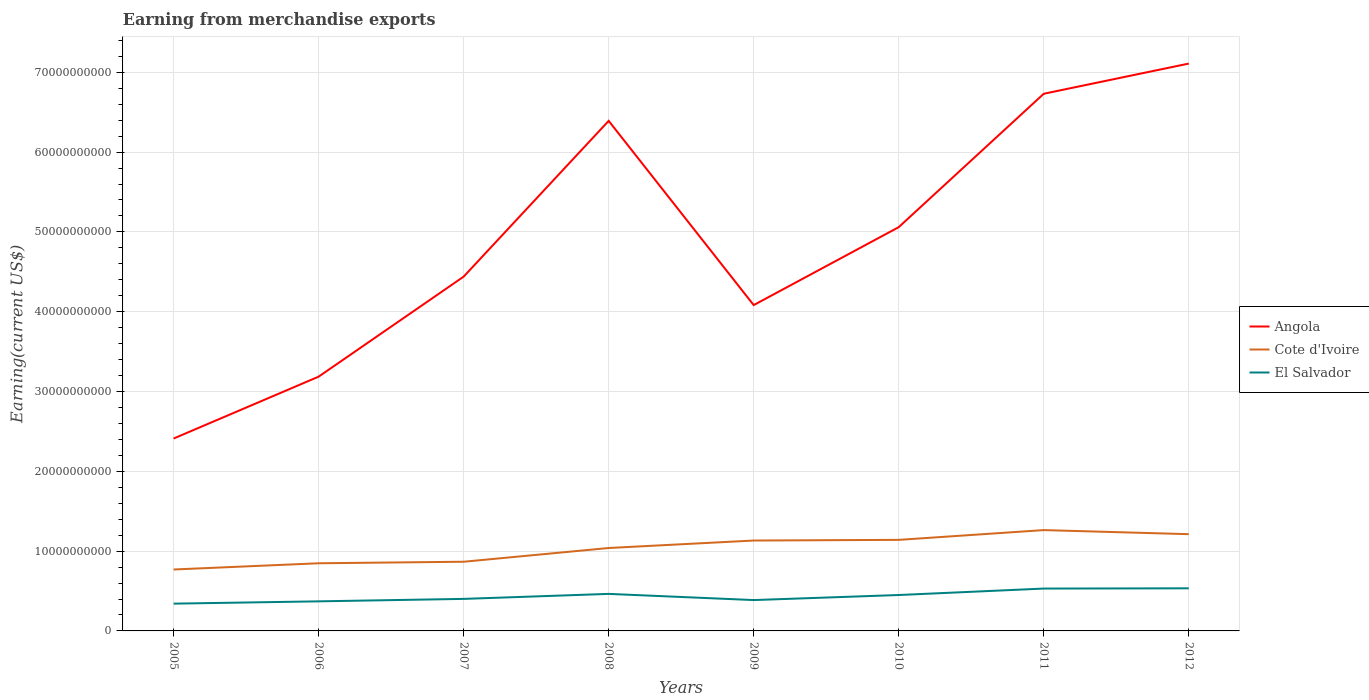How many different coloured lines are there?
Provide a short and direct response. 3. Is the number of lines equal to the number of legend labels?
Provide a short and direct response. Yes. Across all years, what is the maximum amount earned from merchandise exports in Angola?
Ensure brevity in your answer.  2.41e+1. In which year was the amount earned from merchandise exports in El Salvador maximum?
Your response must be concise. 2005. What is the total amount earned from merchandise exports in Cote d'Ivoire in the graph?
Your answer should be compact. -2.74e+09. What is the difference between the highest and the second highest amount earned from merchandise exports in El Salvador?
Keep it short and to the point. 1.92e+09. What is the difference between the highest and the lowest amount earned from merchandise exports in El Salvador?
Provide a short and direct response. 4. How many lines are there?
Provide a short and direct response. 3. How many years are there in the graph?
Provide a short and direct response. 8. What is the difference between two consecutive major ticks on the Y-axis?
Your answer should be very brief. 1.00e+1. Does the graph contain grids?
Offer a terse response. Yes. Where does the legend appear in the graph?
Your answer should be very brief. Center right. How many legend labels are there?
Give a very brief answer. 3. What is the title of the graph?
Your response must be concise. Earning from merchandise exports. What is the label or title of the X-axis?
Provide a short and direct response. Years. What is the label or title of the Y-axis?
Your answer should be compact. Earning(current US$). What is the Earning(current US$) in Angola in 2005?
Your response must be concise. 2.41e+1. What is the Earning(current US$) of Cote d'Ivoire in 2005?
Your answer should be very brief. 7.70e+09. What is the Earning(current US$) of El Salvador in 2005?
Your answer should be compact. 3.42e+09. What is the Earning(current US$) in Angola in 2006?
Offer a very short reply. 3.19e+1. What is the Earning(current US$) in Cote d'Ivoire in 2006?
Keep it short and to the point. 8.48e+09. What is the Earning(current US$) of El Salvador in 2006?
Make the answer very short. 3.71e+09. What is the Earning(current US$) in Angola in 2007?
Offer a very short reply. 4.44e+1. What is the Earning(current US$) in Cote d'Ivoire in 2007?
Your answer should be very brief. 8.67e+09. What is the Earning(current US$) of El Salvador in 2007?
Make the answer very short. 4.01e+09. What is the Earning(current US$) of Angola in 2008?
Your answer should be compact. 6.39e+1. What is the Earning(current US$) of Cote d'Ivoire in 2008?
Provide a short and direct response. 1.04e+1. What is the Earning(current US$) in El Salvador in 2008?
Your answer should be compact. 4.64e+09. What is the Earning(current US$) of Angola in 2009?
Your response must be concise. 4.08e+1. What is the Earning(current US$) of Cote d'Ivoire in 2009?
Offer a very short reply. 1.13e+1. What is the Earning(current US$) in El Salvador in 2009?
Give a very brief answer. 3.87e+09. What is the Earning(current US$) of Angola in 2010?
Offer a terse response. 5.06e+1. What is the Earning(current US$) in Cote d'Ivoire in 2010?
Offer a terse response. 1.14e+1. What is the Earning(current US$) in El Salvador in 2010?
Provide a short and direct response. 4.50e+09. What is the Earning(current US$) of Angola in 2011?
Offer a terse response. 6.73e+1. What is the Earning(current US$) of Cote d'Ivoire in 2011?
Give a very brief answer. 1.26e+1. What is the Earning(current US$) in El Salvador in 2011?
Provide a short and direct response. 5.31e+09. What is the Earning(current US$) in Angola in 2012?
Offer a very short reply. 7.11e+1. What is the Earning(current US$) of Cote d'Ivoire in 2012?
Your response must be concise. 1.21e+1. What is the Earning(current US$) of El Salvador in 2012?
Your answer should be compact. 5.34e+09. Across all years, what is the maximum Earning(current US$) in Angola?
Your response must be concise. 7.11e+1. Across all years, what is the maximum Earning(current US$) of Cote d'Ivoire?
Make the answer very short. 1.26e+1. Across all years, what is the maximum Earning(current US$) in El Salvador?
Ensure brevity in your answer.  5.34e+09. Across all years, what is the minimum Earning(current US$) of Angola?
Keep it short and to the point. 2.41e+1. Across all years, what is the minimum Earning(current US$) in Cote d'Ivoire?
Provide a short and direct response. 7.70e+09. Across all years, what is the minimum Earning(current US$) of El Salvador?
Make the answer very short. 3.42e+09. What is the total Earning(current US$) in Angola in the graph?
Make the answer very short. 3.94e+11. What is the total Earning(current US$) of Cote d'Ivoire in the graph?
Your answer should be very brief. 8.27e+1. What is the total Earning(current US$) of El Salvador in the graph?
Provide a succinct answer. 3.48e+1. What is the difference between the Earning(current US$) of Angola in 2005 and that in 2006?
Make the answer very short. -7.75e+09. What is the difference between the Earning(current US$) in Cote d'Ivoire in 2005 and that in 2006?
Give a very brief answer. -7.80e+08. What is the difference between the Earning(current US$) in El Salvador in 2005 and that in 2006?
Keep it short and to the point. -2.88e+08. What is the difference between the Earning(current US$) in Angola in 2005 and that in 2007?
Ensure brevity in your answer.  -2.03e+1. What is the difference between the Earning(current US$) in Cote d'Ivoire in 2005 and that in 2007?
Your answer should be very brief. -9.72e+08. What is the difference between the Earning(current US$) in El Salvador in 2005 and that in 2007?
Your response must be concise. -5.96e+08. What is the difference between the Earning(current US$) in Angola in 2005 and that in 2008?
Ensure brevity in your answer.  -3.98e+1. What is the difference between the Earning(current US$) of Cote d'Ivoire in 2005 and that in 2008?
Provide a succinct answer. -2.69e+09. What is the difference between the Earning(current US$) in El Salvador in 2005 and that in 2008?
Ensure brevity in your answer.  -1.22e+09. What is the difference between the Earning(current US$) of Angola in 2005 and that in 2009?
Give a very brief answer. -1.67e+1. What is the difference between the Earning(current US$) of Cote d'Ivoire in 2005 and that in 2009?
Your response must be concise. -3.63e+09. What is the difference between the Earning(current US$) in El Salvador in 2005 and that in 2009?
Your answer should be compact. -4.48e+08. What is the difference between the Earning(current US$) of Angola in 2005 and that in 2010?
Make the answer very short. -2.65e+1. What is the difference between the Earning(current US$) of Cote d'Ivoire in 2005 and that in 2010?
Your answer should be very brief. -3.71e+09. What is the difference between the Earning(current US$) in El Salvador in 2005 and that in 2010?
Your answer should be compact. -1.08e+09. What is the difference between the Earning(current US$) of Angola in 2005 and that in 2011?
Offer a terse response. -4.32e+1. What is the difference between the Earning(current US$) of Cote d'Ivoire in 2005 and that in 2011?
Offer a terse response. -4.94e+09. What is the difference between the Earning(current US$) in El Salvador in 2005 and that in 2011?
Your answer should be very brief. -1.89e+09. What is the difference between the Earning(current US$) in Angola in 2005 and that in 2012?
Offer a terse response. -4.70e+1. What is the difference between the Earning(current US$) of Cote d'Ivoire in 2005 and that in 2012?
Your response must be concise. -4.43e+09. What is the difference between the Earning(current US$) of El Salvador in 2005 and that in 2012?
Your answer should be compact. -1.92e+09. What is the difference between the Earning(current US$) of Angola in 2006 and that in 2007?
Make the answer very short. -1.25e+1. What is the difference between the Earning(current US$) in Cote d'Ivoire in 2006 and that in 2007?
Provide a short and direct response. -1.92e+08. What is the difference between the Earning(current US$) of El Salvador in 2006 and that in 2007?
Give a very brief answer. -3.08e+08. What is the difference between the Earning(current US$) of Angola in 2006 and that in 2008?
Give a very brief answer. -3.21e+1. What is the difference between the Earning(current US$) of Cote d'Ivoire in 2006 and that in 2008?
Provide a succinct answer. -1.91e+09. What is the difference between the Earning(current US$) in El Salvador in 2006 and that in 2008?
Make the answer very short. -9.35e+08. What is the difference between the Earning(current US$) in Angola in 2006 and that in 2009?
Your answer should be very brief. -8.97e+09. What is the difference between the Earning(current US$) in Cote d'Ivoire in 2006 and that in 2009?
Ensure brevity in your answer.  -2.85e+09. What is the difference between the Earning(current US$) of El Salvador in 2006 and that in 2009?
Provide a succinct answer. -1.60e+08. What is the difference between the Earning(current US$) of Angola in 2006 and that in 2010?
Provide a succinct answer. -1.87e+1. What is the difference between the Earning(current US$) in Cote d'Ivoire in 2006 and that in 2010?
Provide a succinct answer. -2.93e+09. What is the difference between the Earning(current US$) in El Salvador in 2006 and that in 2010?
Offer a very short reply. -7.93e+08. What is the difference between the Earning(current US$) in Angola in 2006 and that in 2011?
Make the answer very short. -3.54e+1. What is the difference between the Earning(current US$) in Cote d'Ivoire in 2006 and that in 2011?
Your answer should be very brief. -4.16e+09. What is the difference between the Earning(current US$) of El Salvador in 2006 and that in 2011?
Make the answer very short. -1.60e+09. What is the difference between the Earning(current US$) in Angola in 2006 and that in 2012?
Ensure brevity in your answer.  -3.92e+1. What is the difference between the Earning(current US$) of Cote d'Ivoire in 2006 and that in 2012?
Offer a terse response. -3.65e+09. What is the difference between the Earning(current US$) of El Salvador in 2006 and that in 2012?
Your answer should be compact. -1.63e+09. What is the difference between the Earning(current US$) of Angola in 2007 and that in 2008?
Make the answer very short. -1.95e+1. What is the difference between the Earning(current US$) of Cote d'Ivoire in 2007 and that in 2008?
Give a very brief answer. -1.72e+09. What is the difference between the Earning(current US$) of El Salvador in 2007 and that in 2008?
Your answer should be compact. -6.27e+08. What is the difference between the Earning(current US$) of Angola in 2007 and that in 2009?
Provide a succinct answer. 3.57e+09. What is the difference between the Earning(current US$) of Cote d'Ivoire in 2007 and that in 2009?
Offer a terse response. -2.66e+09. What is the difference between the Earning(current US$) in El Salvador in 2007 and that in 2009?
Keep it short and to the point. 1.48e+08. What is the difference between the Earning(current US$) of Angola in 2007 and that in 2010?
Ensure brevity in your answer.  -6.20e+09. What is the difference between the Earning(current US$) of Cote d'Ivoire in 2007 and that in 2010?
Ensure brevity in your answer.  -2.74e+09. What is the difference between the Earning(current US$) in El Salvador in 2007 and that in 2010?
Keep it short and to the point. -4.85e+08. What is the difference between the Earning(current US$) of Angola in 2007 and that in 2011?
Make the answer very short. -2.29e+1. What is the difference between the Earning(current US$) in Cote d'Ivoire in 2007 and that in 2011?
Provide a short and direct response. -3.97e+09. What is the difference between the Earning(current US$) of El Salvador in 2007 and that in 2011?
Make the answer very short. -1.29e+09. What is the difference between the Earning(current US$) of Angola in 2007 and that in 2012?
Provide a succinct answer. -2.67e+1. What is the difference between the Earning(current US$) in Cote d'Ivoire in 2007 and that in 2012?
Keep it short and to the point. -3.46e+09. What is the difference between the Earning(current US$) in El Salvador in 2007 and that in 2012?
Offer a terse response. -1.32e+09. What is the difference between the Earning(current US$) of Angola in 2008 and that in 2009?
Make the answer very short. 2.31e+1. What is the difference between the Earning(current US$) of Cote d'Ivoire in 2008 and that in 2009?
Provide a succinct answer. -9.37e+08. What is the difference between the Earning(current US$) in El Salvador in 2008 and that in 2009?
Give a very brief answer. 7.75e+08. What is the difference between the Earning(current US$) of Angola in 2008 and that in 2010?
Ensure brevity in your answer.  1.33e+1. What is the difference between the Earning(current US$) of Cote d'Ivoire in 2008 and that in 2010?
Your response must be concise. -1.02e+09. What is the difference between the Earning(current US$) in El Salvador in 2008 and that in 2010?
Provide a short and direct response. 1.42e+08. What is the difference between the Earning(current US$) of Angola in 2008 and that in 2011?
Provide a short and direct response. -3.40e+09. What is the difference between the Earning(current US$) in Cote d'Ivoire in 2008 and that in 2011?
Provide a succinct answer. -2.25e+09. What is the difference between the Earning(current US$) in El Salvador in 2008 and that in 2011?
Offer a terse response. -6.67e+08. What is the difference between the Earning(current US$) in Angola in 2008 and that in 2012?
Provide a succinct answer. -7.18e+09. What is the difference between the Earning(current US$) of Cote d'Ivoire in 2008 and that in 2012?
Provide a short and direct response. -1.73e+09. What is the difference between the Earning(current US$) of El Salvador in 2008 and that in 2012?
Give a very brief answer. -6.98e+08. What is the difference between the Earning(current US$) in Angola in 2009 and that in 2010?
Make the answer very short. -9.77e+09. What is the difference between the Earning(current US$) of Cote d'Ivoire in 2009 and that in 2010?
Keep it short and to the point. -8.33e+07. What is the difference between the Earning(current US$) in El Salvador in 2009 and that in 2010?
Your response must be concise. -6.33e+08. What is the difference between the Earning(current US$) in Angola in 2009 and that in 2011?
Your answer should be compact. -2.65e+1. What is the difference between the Earning(current US$) in Cote d'Ivoire in 2009 and that in 2011?
Provide a short and direct response. -1.31e+09. What is the difference between the Earning(current US$) of El Salvador in 2009 and that in 2011?
Offer a terse response. -1.44e+09. What is the difference between the Earning(current US$) of Angola in 2009 and that in 2012?
Your answer should be compact. -3.03e+1. What is the difference between the Earning(current US$) of Cote d'Ivoire in 2009 and that in 2012?
Ensure brevity in your answer.  -7.97e+08. What is the difference between the Earning(current US$) of El Salvador in 2009 and that in 2012?
Make the answer very short. -1.47e+09. What is the difference between the Earning(current US$) of Angola in 2010 and that in 2011?
Your response must be concise. -1.67e+1. What is the difference between the Earning(current US$) in Cote d'Ivoire in 2010 and that in 2011?
Ensure brevity in your answer.  -1.22e+09. What is the difference between the Earning(current US$) of El Salvador in 2010 and that in 2011?
Provide a short and direct response. -8.09e+08. What is the difference between the Earning(current US$) in Angola in 2010 and that in 2012?
Provide a succinct answer. -2.05e+1. What is the difference between the Earning(current US$) of Cote d'Ivoire in 2010 and that in 2012?
Provide a succinct answer. -7.14e+08. What is the difference between the Earning(current US$) in El Salvador in 2010 and that in 2012?
Offer a terse response. -8.40e+08. What is the difference between the Earning(current US$) of Angola in 2011 and that in 2012?
Your response must be concise. -3.78e+09. What is the difference between the Earning(current US$) in Cote d'Ivoire in 2011 and that in 2012?
Provide a short and direct response. 5.11e+08. What is the difference between the Earning(current US$) of El Salvador in 2011 and that in 2012?
Your response must be concise. -3.08e+07. What is the difference between the Earning(current US$) in Angola in 2005 and the Earning(current US$) in Cote d'Ivoire in 2006?
Offer a terse response. 1.56e+1. What is the difference between the Earning(current US$) of Angola in 2005 and the Earning(current US$) of El Salvador in 2006?
Provide a short and direct response. 2.04e+1. What is the difference between the Earning(current US$) of Cote d'Ivoire in 2005 and the Earning(current US$) of El Salvador in 2006?
Your response must be concise. 3.99e+09. What is the difference between the Earning(current US$) in Angola in 2005 and the Earning(current US$) in Cote d'Ivoire in 2007?
Your answer should be very brief. 1.54e+1. What is the difference between the Earning(current US$) of Angola in 2005 and the Earning(current US$) of El Salvador in 2007?
Give a very brief answer. 2.01e+1. What is the difference between the Earning(current US$) of Cote d'Ivoire in 2005 and the Earning(current US$) of El Salvador in 2007?
Provide a short and direct response. 3.68e+09. What is the difference between the Earning(current US$) in Angola in 2005 and the Earning(current US$) in Cote d'Ivoire in 2008?
Your response must be concise. 1.37e+1. What is the difference between the Earning(current US$) in Angola in 2005 and the Earning(current US$) in El Salvador in 2008?
Offer a very short reply. 1.95e+1. What is the difference between the Earning(current US$) of Cote d'Ivoire in 2005 and the Earning(current US$) of El Salvador in 2008?
Keep it short and to the point. 3.06e+09. What is the difference between the Earning(current US$) in Angola in 2005 and the Earning(current US$) in Cote d'Ivoire in 2009?
Keep it short and to the point. 1.28e+1. What is the difference between the Earning(current US$) in Angola in 2005 and the Earning(current US$) in El Salvador in 2009?
Keep it short and to the point. 2.02e+1. What is the difference between the Earning(current US$) in Cote d'Ivoire in 2005 and the Earning(current US$) in El Salvador in 2009?
Keep it short and to the point. 3.83e+09. What is the difference between the Earning(current US$) of Angola in 2005 and the Earning(current US$) of Cote d'Ivoire in 2010?
Offer a terse response. 1.27e+1. What is the difference between the Earning(current US$) of Angola in 2005 and the Earning(current US$) of El Salvador in 2010?
Your response must be concise. 1.96e+1. What is the difference between the Earning(current US$) of Cote d'Ivoire in 2005 and the Earning(current US$) of El Salvador in 2010?
Your answer should be very brief. 3.20e+09. What is the difference between the Earning(current US$) in Angola in 2005 and the Earning(current US$) in Cote d'Ivoire in 2011?
Offer a very short reply. 1.15e+1. What is the difference between the Earning(current US$) in Angola in 2005 and the Earning(current US$) in El Salvador in 2011?
Your answer should be compact. 1.88e+1. What is the difference between the Earning(current US$) of Cote d'Ivoire in 2005 and the Earning(current US$) of El Salvador in 2011?
Make the answer very short. 2.39e+09. What is the difference between the Earning(current US$) of Angola in 2005 and the Earning(current US$) of Cote d'Ivoire in 2012?
Offer a terse response. 1.20e+1. What is the difference between the Earning(current US$) in Angola in 2005 and the Earning(current US$) in El Salvador in 2012?
Ensure brevity in your answer.  1.88e+1. What is the difference between the Earning(current US$) in Cote d'Ivoire in 2005 and the Earning(current US$) in El Salvador in 2012?
Make the answer very short. 2.36e+09. What is the difference between the Earning(current US$) of Angola in 2006 and the Earning(current US$) of Cote d'Ivoire in 2007?
Offer a very short reply. 2.32e+1. What is the difference between the Earning(current US$) of Angola in 2006 and the Earning(current US$) of El Salvador in 2007?
Make the answer very short. 2.78e+1. What is the difference between the Earning(current US$) in Cote d'Ivoire in 2006 and the Earning(current US$) in El Salvador in 2007?
Your response must be concise. 4.46e+09. What is the difference between the Earning(current US$) of Angola in 2006 and the Earning(current US$) of Cote d'Ivoire in 2008?
Keep it short and to the point. 2.15e+1. What is the difference between the Earning(current US$) in Angola in 2006 and the Earning(current US$) in El Salvador in 2008?
Your response must be concise. 2.72e+1. What is the difference between the Earning(current US$) in Cote d'Ivoire in 2006 and the Earning(current US$) in El Salvador in 2008?
Your answer should be very brief. 3.84e+09. What is the difference between the Earning(current US$) in Angola in 2006 and the Earning(current US$) in Cote d'Ivoire in 2009?
Keep it short and to the point. 2.05e+1. What is the difference between the Earning(current US$) of Angola in 2006 and the Earning(current US$) of El Salvador in 2009?
Provide a succinct answer. 2.80e+1. What is the difference between the Earning(current US$) in Cote d'Ivoire in 2006 and the Earning(current US$) in El Salvador in 2009?
Your answer should be compact. 4.61e+09. What is the difference between the Earning(current US$) of Angola in 2006 and the Earning(current US$) of Cote d'Ivoire in 2010?
Your answer should be compact. 2.05e+1. What is the difference between the Earning(current US$) in Angola in 2006 and the Earning(current US$) in El Salvador in 2010?
Offer a very short reply. 2.74e+1. What is the difference between the Earning(current US$) of Cote d'Ivoire in 2006 and the Earning(current US$) of El Salvador in 2010?
Provide a succinct answer. 3.98e+09. What is the difference between the Earning(current US$) of Angola in 2006 and the Earning(current US$) of Cote d'Ivoire in 2011?
Your answer should be very brief. 1.92e+1. What is the difference between the Earning(current US$) of Angola in 2006 and the Earning(current US$) of El Salvador in 2011?
Your response must be concise. 2.66e+1. What is the difference between the Earning(current US$) in Cote d'Ivoire in 2006 and the Earning(current US$) in El Salvador in 2011?
Keep it short and to the point. 3.17e+09. What is the difference between the Earning(current US$) of Angola in 2006 and the Earning(current US$) of Cote d'Ivoire in 2012?
Provide a short and direct response. 1.97e+1. What is the difference between the Earning(current US$) of Angola in 2006 and the Earning(current US$) of El Salvador in 2012?
Provide a short and direct response. 2.65e+1. What is the difference between the Earning(current US$) of Cote d'Ivoire in 2006 and the Earning(current US$) of El Salvador in 2012?
Provide a succinct answer. 3.14e+09. What is the difference between the Earning(current US$) in Angola in 2007 and the Earning(current US$) in Cote d'Ivoire in 2008?
Make the answer very short. 3.40e+1. What is the difference between the Earning(current US$) in Angola in 2007 and the Earning(current US$) in El Salvador in 2008?
Ensure brevity in your answer.  3.98e+1. What is the difference between the Earning(current US$) in Cote d'Ivoire in 2007 and the Earning(current US$) in El Salvador in 2008?
Offer a terse response. 4.03e+09. What is the difference between the Earning(current US$) of Angola in 2007 and the Earning(current US$) of Cote d'Ivoire in 2009?
Make the answer very short. 3.31e+1. What is the difference between the Earning(current US$) of Angola in 2007 and the Earning(current US$) of El Salvador in 2009?
Make the answer very short. 4.05e+1. What is the difference between the Earning(current US$) in Cote d'Ivoire in 2007 and the Earning(current US$) in El Salvador in 2009?
Provide a succinct answer. 4.80e+09. What is the difference between the Earning(current US$) of Angola in 2007 and the Earning(current US$) of Cote d'Ivoire in 2010?
Your answer should be compact. 3.30e+1. What is the difference between the Earning(current US$) of Angola in 2007 and the Earning(current US$) of El Salvador in 2010?
Make the answer very short. 3.99e+1. What is the difference between the Earning(current US$) in Cote d'Ivoire in 2007 and the Earning(current US$) in El Salvador in 2010?
Your response must be concise. 4.17e+09. What is the difference between the Earning(current US$) in Angola in 2007 and the Earning(current US$) in Cote d'Ivoire in 2011?
Offer a terse response. 3.18e+1. What is the difference between the Earning(current US$) in Angola in 2007 and the Earning(current US$) in El Salvador in 2011?
Offer a terse response. 3.91e+1. What is the difference between the Earning(current US$) of Cote d'Ivoire in 2007 and the Earning(current US$) of El Salvador in 2011?
Your response must be concise. 3.36e+09. What is the difference between the Earning(current US$) in Angola in 2007 and the Earning(current US$) in Cote d'Ivoire in 2012?
Provide a succinct answer. 3.23e+1. What is the difference between the Earning(current US$) of Angola in 2007 and the Earning(current US$) of El Salvador in 2012?
Provide a succinct answer. 3.91e+1. What is the difference between the Earning(current US$) of Cote d'Ivoire in 2007 and the Earning(current US$) of El Salvador in 2012?
Your response must be concise. 3.33e+09. What is the difference between the Earning(current US$) in Angola in 2008 and the Earning(current US$) in Cote d'Ivoire in 2009?
Offer a very short reply. 5.26e+1. What is the difference between the Earning(current US$) in Angola in 2008 and the Earning(current US$) in El Salvador in 2009?
Give a very brief answer. 6.00e+1. What is the difference between the Earning(current US$) in Cote d'Ivoire in 2008 and the Earning(current US$) in El Salvador in 2009?
Give a very brief answer. 6.52e+09. What is the difference between the Earning(current US$) in Angola in 2008 and the Earning(current US$) in Cote d'Ivoire in 2010?
Provide a short and direct response. 5.25e+1. What is the difference between the Earning(current US$) in Angola in 2008 and the Earning(current US$) in El Salvador in 2010?
Provide a succinct answer. 5.94e+1. What is the difference between the Earning(current US$) in Cote d'Ivoire in 2008 and the Earning(current US$) in El Salvador in 2010?
Your response must be concise. 5.89e+09. What is the difference between the Earning(current US$) in Angola in 2008 and the Earning(current US$) in Cote d'Ivoire in 2011?
Your response must be concise. 5.13e+1. What is the difference between the Earning(current US$) of Angola in 2008 and the Earning(current US$) of El Salvador in 2011?
Your response must be concise. 5.86e+1. What is the difference between the Earning(current US$) in Cote d'Ivoire in 2008 and the Earning(current US$) in El Salvador in 2011?
Provide a succinct answer. 5.08e+09. What is the difference between the Earning(current US$) of Angola in 2008 and the Earning(current US$) of Cote d'Ivoire in 2012?
Keep it short and to the point. 5.18e+1. What is the difference between the Earning(current US$) of Angola in 2008 and the Earning(current US$) of El Salvador in 2012?
Offer a terse response. 5.86e+1. What is the difference between the Earning(current US$) of Cote d'Ivoire in 2008 and the Earning(current US$) of El Salvador in 2012?
Provide a short and direct response. 5.05e+09. What is the difference between the Earning(current US$) of Angola in 2009 and the Earning(current US$) of Cote d'Ivoire in 2010?
Keep it short and to the point. 2.94e+1. What is the difference between the Earning(current US$) of Angola in 2009 and the Earning(current US$) of El Salvador in 2010?
Provide a succinct answer. 3.63e+1. What is the difference between the Earning(current US$) of Cote d'Ivoire in 2009 and the Earning(current US$) of El Salvador in 2010?
Offer a very short reply. 6.83e+09. What is the difference between the Earning(current US$) in Angola in 2009 and the Earning(current US$) in Cote d'Ivoire in 2011?
Ensure brevity in your answer.  2.82e+1. What is the difference between the Earning(current US$) of Angola in 2009 and the Earning(current US$) of El Salvador in 2011?
Your response must be concise. 3.55e+1. What is the difference between the Earning(current US$) of Cote d'Ivoire in 2009 and the Earning(current US$) of El Salvador in 2011?
Ensure brevity in your answer.  6.02e+09. What is the difference between the Earning(current US$) in Angola in 2009 and the Earning(current US$) in Cote d'Ivoire in 2012?
Provide a succinct answer. 2.87e+1. What is the difference between the Earning(current US$) of Angola in 2009 and the Earning(current US$) of El Salvador in 2012?
Your response must be concise. 3.55e+1. What is the difference between the Earning(current US$) in Cote d'Ivoire in 2009 and the Earning(current US$) in El Salvador in 2012?
Provide a short and direct response. 5.99e+09. What is the difference between the Earning(current US$) in Angola in 2010 and the Earning(current US$) in Cote d'Ivoire in 2011?
Make the answer very short. 3.80e+1. What is the difference between the Earning(current US$) of Angola in 2010 and the Earning(current US$) of El Salvador in 2011?
Your answer should be very brief. 4.53e+1. What is the difference between the Earning(current US$) of Cote d'Ivoire in 2010 and the Earning(current US$) of El Salvador in 2011?
Ensure brevity in your answer.  6.10e+09. What is the difference between the Earning(current US$) of Angola in 2010 and the Earning(current US$) of Cote d'Ivoire in 2012?
Make the answer very short. 3.85e+1. What is the difference between the Earning(current US$) of Angola in 2010 and the Earning(current US$) of El Salvador in 2012?
Offer a very short reply. 4.53e+1. What is the difference between the Earning(current US$) in Cote d'Ivoire in 2010 and the Earning(current US$) in El Salvador in 2012?
Provide a succinct answer. 6.07e+09. What is the difference between the Earning(current US$) of Angola in 2011 and the Earning(current US$) of Cote d'Ivoire in 2012?
Give a very brief answer. 5.52e+1. What is the difference between the Earning(current US$) of Angola in 2011 and the Earning(current US$) of El Salvador in 2012?
Offer a very short reply. 6.20e+1. What is the difference between the Earning(current US$) in Cote d'Ivoire in 2011 and the Earning(current US$) in El Salvador in 2012?
Your response must be concise. 7.30e+09. What is the average Earning(current US$) of Angola per year?
Your response must be concise. 4.93e+1. What is the average Earning(current US$) in Cote d'Ivoire per year?
Your answer should be very brief. 1.03e+1. What is the average Earning(current US$) in El Salvador per year?
Offer a terse response. 4.35e+09. In the year 2005, what is the difference between the Earning(current US$) in Angola and Earning(current US$) in Cote d'Ivoire?
Provide a short and direct response. 1.64e+1. In the year 2005, what is the difference between the Earning(current US$) in Angola and Earning(current US$) in El Salvador?
Your response must be concise. 2.07e+1. In the year 2005, what is the difference between the Earning(current US$) of Cote d'Ivoire and Earning(current US$) of El Salvador?
Give a very brief answer. 4.28e+09. In the year 2006, what is the difference between the Earning(current US$) of Angola and Earning(current US$) of Cote d'Ivoire?
Your answer should be compact. 2.34e+1. In the year 2006, what is the difference between the Earning(current US$) of Angola and Earning(current US$) of El Salvador?
Give a very brief answer. 2.82e+1. In the year 2006, what is the difference between the Earning(current US$) in Cote d'Ivoire and Earning(current US$) in El Salvador?
Provide a short and direct response. 4.77e+09. In the year 2007, what is the difference between the Earning(current US$) in Angola and Earning(current US$) in Cote d'Ivoire?
Keep it short and to the point. 3.57e+1. In the year 2007, what is the difference between the Earning(current US$) of Angola and Earning(current US$) of El Salvador?
Keep it short and to the point. 4.04e+1. In the year 2007, what is the difference between the Earning(current US$) of Cote d'Ivoire and Earning(current US$) of El Salvador?
Make the answer very short. 4.65e+09. In the year 2008, what is the difference between the Earning(current US$) in Angola and Earning(current US$) in Cote d'Ivoire?
Offer a very short reply. 5.35e+1. In the year 2008, what is the difference between the Earning(current US$) in Angola and Earning(current US$) in El Salvador?
Ensure brevity in your answer.  5.93e+1. In the year 2008, what is the difference between the Earning(current US$) in Cote d'Ivoire and Earning(current US$) in El Salvador?
Offer a very short reply. 5.75e+09. In the year 2009, what is the difference between the Earning(current US$) in Angola and Earning(current US$) in Cote d'Ivoire?
Your response must be concise. 2.95e+1. In the year 2009, what is the difference between the Earning(current US$) of Angola and Earning(current US$) of El Salvador?
Provide a succinct answer. 3.70e+1. In the year 2009, what is the difference between the Earning(current US$) in Cote d'Ivoire and Earning(current US$) in El Salvador?
Ensure brevity in your answer.  7.46e+09. In the year 2010, what is the difference between the Earning(current US$) of Angola and Earning(current US$) of Cote d'Ivoire?
Your answer should be compact. 3.92e+1. In the year 2010, what is the difference between the Earning(current US$) in Angola and Earning(current US$) in El Salvador?
Your answer should be very brief. 4.61e+1. In the year 2010, what is the difference between the Earning(current US$) in Cote d'Ivoire and Earning(current US$) in El Salvador?
Your answer should be very brief. 6.91e+09. In the year 2011, what is the difference between the Earning(current US$) in Angola and Earning(current US$) in Cote d'Ivoire?
Offer a very short reply. 5.47e+1. In the year 2011, what is the difference between the Earning(current US$) of Angola and Earning(current US$) of El Salvador?
Keep it short and to the point. 6.20e+1. In the year 2011, what is the difference between the Earning(current US$) of Cote d'Ivoire and Earning(current US$) of El Salvador?
Provide a short and direct response. 7.33e+09. In the year 2012, what is the difference between the Earning(current US$) of Angola and Earning(current US$) of Cote d'Ivoire?
Give a very brief answer. 5.90e+1. In the year 2012, what is the difference between the Earning(current US$) of Angola and Earning(current US$) of El Salvador?
Your answer should be very brief. 6.58e+1. In the year 2012, what is the difference between the Earning(current US$) in Cote d'Ivoire and Earning(current US$) in El Salvador?
Make the answer very short. 6.78e+09. What is the ratio of the Earning(current US$) in Angola in 2005 to that in 2006?
Give a very brief answer. 0.76. What is the ratio of the Earning(current US$) of Cote d'Ivoire in 2005 to that in 2006?
Keep it short and to the point. 0.91. What is the ratio of the Earning(current US$) of El Salvador in 2005 to that in 2006?
Your answer should be very brief. 0.92. What is the ratio of the Earning(current US$) in Angola in 2005 to that in 2007?
Provide a short and direct response. 0.54. What is the ratio of the Earning(current US$) of Cote d'Ivoire in 2005 to that in 2007?
Give a very brief answer. 0.89. What is the ratio of the Earning(current US$) in El Salvador in 2005 to that in 2007?
Give a very brief answer. 0.85. What is the ratio of the Earning(current US$) of Angola in 2005 to that in 2008?
Make the answer very short. 0.38. What is the ratio of the Earning(current US$) in Cote d'Ivoire in 2005 to that in 2008?
Offer a very short reply. 0.74. What is the ratio of the Earning(current US$) in El Salvador in 2005 to that in 2008?
Offer a terse response. 0.74. What is the ratio of the Earning(current US$) of Angola in 2005 to that in 2009?
Your answer should be compact. 0.59. What is the ratio of the Earning(current US$) in Cote d'Ivoire in 2005 to that in 2009?
Your answer should be very brief. 0.68. What is the ratio of the Earning(current US$) in El Salvador in 2005 to that in 2009?
Provide a succinct answer. 0.88. What is the ratio of the Earning(current US$) of Angola in 2005 to that in 2010?
Provide a succinct answer. 0.48. What is the ratio of the Earning(current US$) in Cote d'Ivoire in 2005 to that in 2010?
Provide a succinct answer. 0.67. What is the ratio of the Earning(current US$) in El Salvador in 2005 to that in 2010?
Ensure brevity in your answer.  0.76. What is the ratio of the Earning(current US$) of Angola in 2005 to that in 2011?
Make the answer very short. 0.36. What is the ratio of the Earning(current US$) of Cote d'Ivoire in 2005 to that in 2011?
Provide a succinct answer. 0.61. What is the ratio of the Earning(current US$) of El Salvador in 2005 to that in 2011?
Give a very brief answer. 0.64. What is the ratio of the Earning(current US$) in Angola in 2005 to that in 2012?
Make the answer very short. 0.34. What is the ratio of the Earning(current US$) in Cote d'Ivoire in 2005 to that in 2012?
Keep it short and to the point. 0.63. What is the ratio of the Earning(current US$) in El Salvador in 2005 to that in 2012?
Your answer should be compact. 0.64. What is the ratio of the Earning(current US$) in Angola in 2006 to that in 2007?
Offer a very short reply. 0.72. What is the ratio of the Earning(current US$) of Cote d'Ivoire in 2006 to that in 2007?
Make the answer very short. 0.98. What is the ratio of the Earning(current US$) in El Salvador in 2006 to that in 2007?
Your answer should be very brief. 0.92. What is the ratio of the Earning(current US$) of Angola in 2006 to that in 2008?
Offer a very short reply. 0.5. What is the ratio of the Earning(current US$) of Cote d'Ivoire in 2006 to that in 2008?
Give a very brief answer. 0.82. What is the ratio of the Earning(current US$) in El Salvador in 2006 to that in 2008?
Offer a very short reply. 0.8. What is the ratio of the Earning(current US$) of Angola in 2006 to that in 2009?
Make the answer very short. 0.78. What is the ratio of the Earning(current US$) in Cote d'Ivoire in 2006 to that in 2009?
Your response must be concise. 0.75. What is the ratio of the Earning(current US$) of El Salvador in 2006 to that in 2009?
Give a very brief answer. 0.96. What is the ratio of the Earning(current US$) in Angola in 2006 to that in 2010?
Offer a terse response. 0.63. What is the ratio of the Earning(current US$) in Cote d'Ivoire in 2006 to that in 2010?
Offer a very short reply. 0.74. What is the ratio of the Earning(current US$) of El Salvador in 2006 to that in 2010?
Make the answer very short. 0.82. What is the ratio of the Earning(current US$) in Angola in 2006 to that in 2011?
Ensure brevity in your answer.  0.47. What is the ratio of the Earning(current US$) in Cote d'Ivoire in 2006 to that in 2011?
Your answer should be compact. 0.67. What is the ratio of the Earning(current US$) of El Salvador in 2006 to that in 2011?
Your response must be concise. 0.7. What is the ratio of the Earning(current US$) in Angola in 2006 to that in 2012?
Your answer should be compact. 0.45. What is the ratio of the Earning(current US$) of Cote d'Ivoire in 2006 to that in 2012?
Give a very brief answer. 0.7. What is the ratio of the Earning(current US$) of El Salvador in 2006 to that in 2012?
Your answer should be compact. 0.69. What is the ratio of the Earning(current US$) in Angola in 2007 to that in 2008?
Your response must be concise. 0.69. What is the ratio of the Earning(current US$) in Cote d'Ivoire in 2007 to that in 2008?
Provide a succinct answer. 0.83. What is the ratio of the Earning(current US$) of El Salvador in 2007 to that in 2008?
Give a very brief answer. 0.86. What is the ratio of the Earning(current US$) of Angola in 2007 to that in 2009?
Give a very brief answer. 1.09. What is the ratio of the Earning(current US$) in Cote d'Ivoire in 2007 to that in 2009?
Give a very brief answer. 0.77. What is the ratio of the Earning(current US$) of El Salvador in 2007 to that in 2009?
Your response must be concise. 1.04. What is the ratio of the Earning(current US$) in Angola in 2007 to that in 2010?
Your response must be concise. 0.88. What is the ratio of the Earning(current US$) in Cote d'Ivoire in 2007 to that in 2010?
Keep it short and to the point. 0.76. What is the ratio of the Earning(current US$) of El Salvador in 2007 to that in 2010?
Your response must be concise. 0.89. What is the ratio of the Earning(current US$) in Angola in 2007 to that in 2011?
Your answer should be compact. 0.66. What is the ratio of the Earning(current US$) in Cote d'Ivoire in 2007 to that in 2011?
Ensure brevity in your answer.  0.69. What is the ratio of the Earning(current US$) of El Salvador in 2007 to that in 2011?
Provide a succinct answer. 0.76. What is the ratio of the Earning(current US$) of Angola in 2007 to that in 2012?
Ensure brevity in your answer.  0.62. What is the ratio of the Earning(current US$) of Cote d'Ivoire in 2007 to that in 2012?
Provide a succinct answer. 0.71. What is the ratio of the Earning(current US$) of El Salvador in 2007 to that in 2012?
Offer a very short reply. 0.75. What is the ratio of the Earning(current US$) of Angola in 2008 to that in 2009?
Your answer should be very brief. 1.57. What is the ratio of the Earning(current US$) in Cote d'Ivoire in 2008 to that in 2009?
Make the answer very short. 0.92. What is the ratio of the Earning(current US$) in El Salvador in 2008 to that in 2009?
Provide a short and direct response. 1.2. What is the ratio of the Earning(current US$) in Angola in 2008 to that in 2010?
Ensure brevity in your answer.  1.26. What is the ratio of the Earning(current US$) in Cote d'Ivoire in 2008 to that in 2010?
Make the answer very short. 0.91. What is the ratio of the Earning(current US$) of El Salvador in 2008 to that in 2010?
Provide a succinct answer. 1.03. What is the ratio of the Earning(current US$) in Angola in 2008 to that in 2011?
Your response must be concise. 0.95. What is the ratio of the Earning(current US$) in Cote d'Ivoire in 2008 to that in 2011?
Ensure brevity in your answer.  0.82. What is the ratio of the Earning(current US$) in El Salvador in 2008 to that in 2011?
Give a very brief answer. 0.87. What is the ratio of the Earning(current US$) of Angola in 2008 to that in 2012?
Offer a very short reply. 0.9. What is the ratio of the Earning(current US$) in Cote d'Ivoire in 2008 to that in 2012?
Offer a terse response. 0.86. What is the ratio of the Earning(current US$) of El Salvador in 2008 to that in 2012?
Your answer should be very brief. 0.87. What is the ratio of the Earning(current US$) of Angola in 2009 to that in 2010?
Provide a succinct answer. 0.81. What is the ratio of the Earning(current US$) in El Salvador in 2009 to that in 2010?
Keep it short and to the point. 0.86. What is the ratio of the Earning(current US$) in Angola in 2009 to that in 2011?
Make the answer very short. 0.61. What is the ratio of the Earning(current US$) of Cote d'Ivoire in 2009 to that in 2011?
Make the answer very short. 0.9. What is the ratio of the Earning(current US$) in El Salvador in 2009 to that in 2011?
Make the answer very short. 0.73. What is the ratio of the Earning(current US$) in Angola in 2009 to that in 2012?
Provide a short and direct response. 0.57. What is the ratio of the Earning(current US$) of Cote d'Ivoire in 2009 to that in 2012?
Your answer should be very brief. 0.93. What is the ratio of the Earning(current US$) of El Salvador in 2009 to that in 2012?
Offer a very short reply. 0.72. What is the ratio of the Earning(current US$) of Angola in 2010 to that in 2011?
Offer a terse response. 0.75. What is the ratio of the Earning(current US$) of Cote d'Ivoire in 2010 to that in 2011?
Your answer should be compact. 0.9. What is the ratio of the Earning(current US$) of El Salvador in 2010 to that in 2011?
Offer a very short reply. 0.85. What is the ratio of the Earning(current US$) in Angola in 2010 to that in 2012?
Provide a short and direct response. 0.71. What is the ratio of the Earning(current US$) of Cote d'Ivoire in 2010 to that in 2012?
Provide a short and direct response. 0.94. What is the ratio of the Earning(current US$) of El Salvador in 2010 to that in 2012?
Your answer should be compact. 0.84. What is the ratio of the Earning(current US$) in Angola in 2011 to that in 2012?
Provide a short and direct response. 0.95. What is the ratio of the Earning(current US$) of Cote d'Ivoire in 2011 to that in 2012?
Your response must be concise. 1.04. What is the ratio of the Earning(current US$) of El Salvador in 2011 to that in 2012?
Your answer should be compact. 0.99. What is the difference between the highest and the second highest Earning(current US$) of Angola?
Make the answer very short. 3.78e+09. What is the difference between the highest and the second highest Earning(current US$) of Cote d'Ivoire?
Provide a succinct answer. 5.11e+08. What is the difference between the highest and the second highest Earning(current US$) of El Salvador?
Provide a succinct answer. 3.08e+07. What is the difference between the highest and the lowest Earning(current US$) in Angola?
Give a very brief answer. 4.70e+1. What is the difference between the highest and the lowest Earning(current US$) of Cote d'Ivoire?
Give a very brief answer. 4.94e+09. What is the difference between the highest and the lowest Earning(current US$) of El Salvador?
Provide a succinct answer. 1.92e+09. 